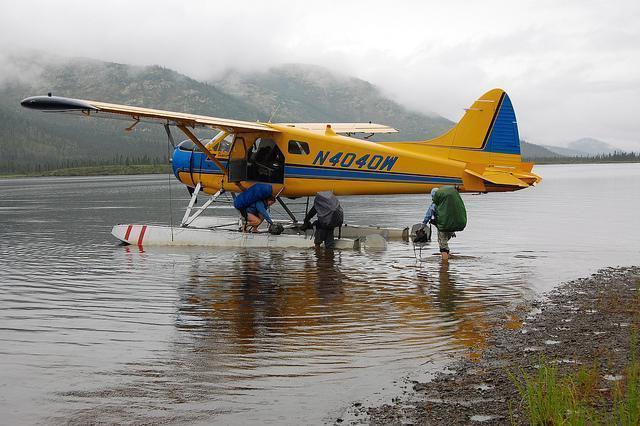What type of plane is being boarded?
Select the accurate response from the four choices given to answer the question.
Options: 747, jet, helicopter, pontoon. Pontoon. 